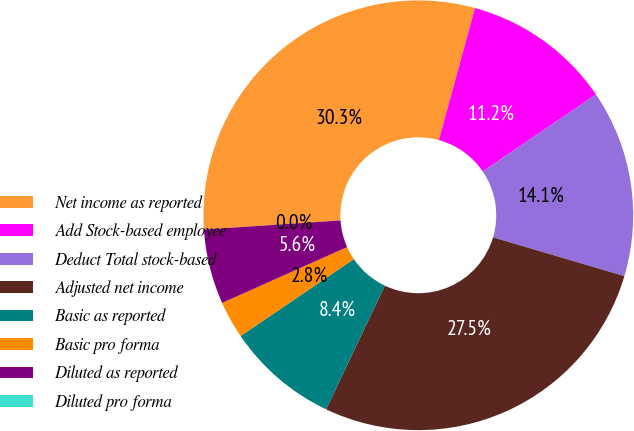<chart> <loc_0><loc_0><loc_500><loc_500><pie_chart><fcel>Net income as reported<fcel>Add Stock-based employee<fcel>Deduct Total stock-based<fcel>Adjusted net income<fcel>Basic as reported<fcel>Basic pro forma<fcel>Diluted as reported<fcel>Diluted pro forma<nl><fcel>30.31%<fcel>11.25%<fcel>14.07%<fcel>27.49%<fcel>8.44%<fcel>2.81%<fcel>5.63%<fcel>0.0%<nl></chart> 